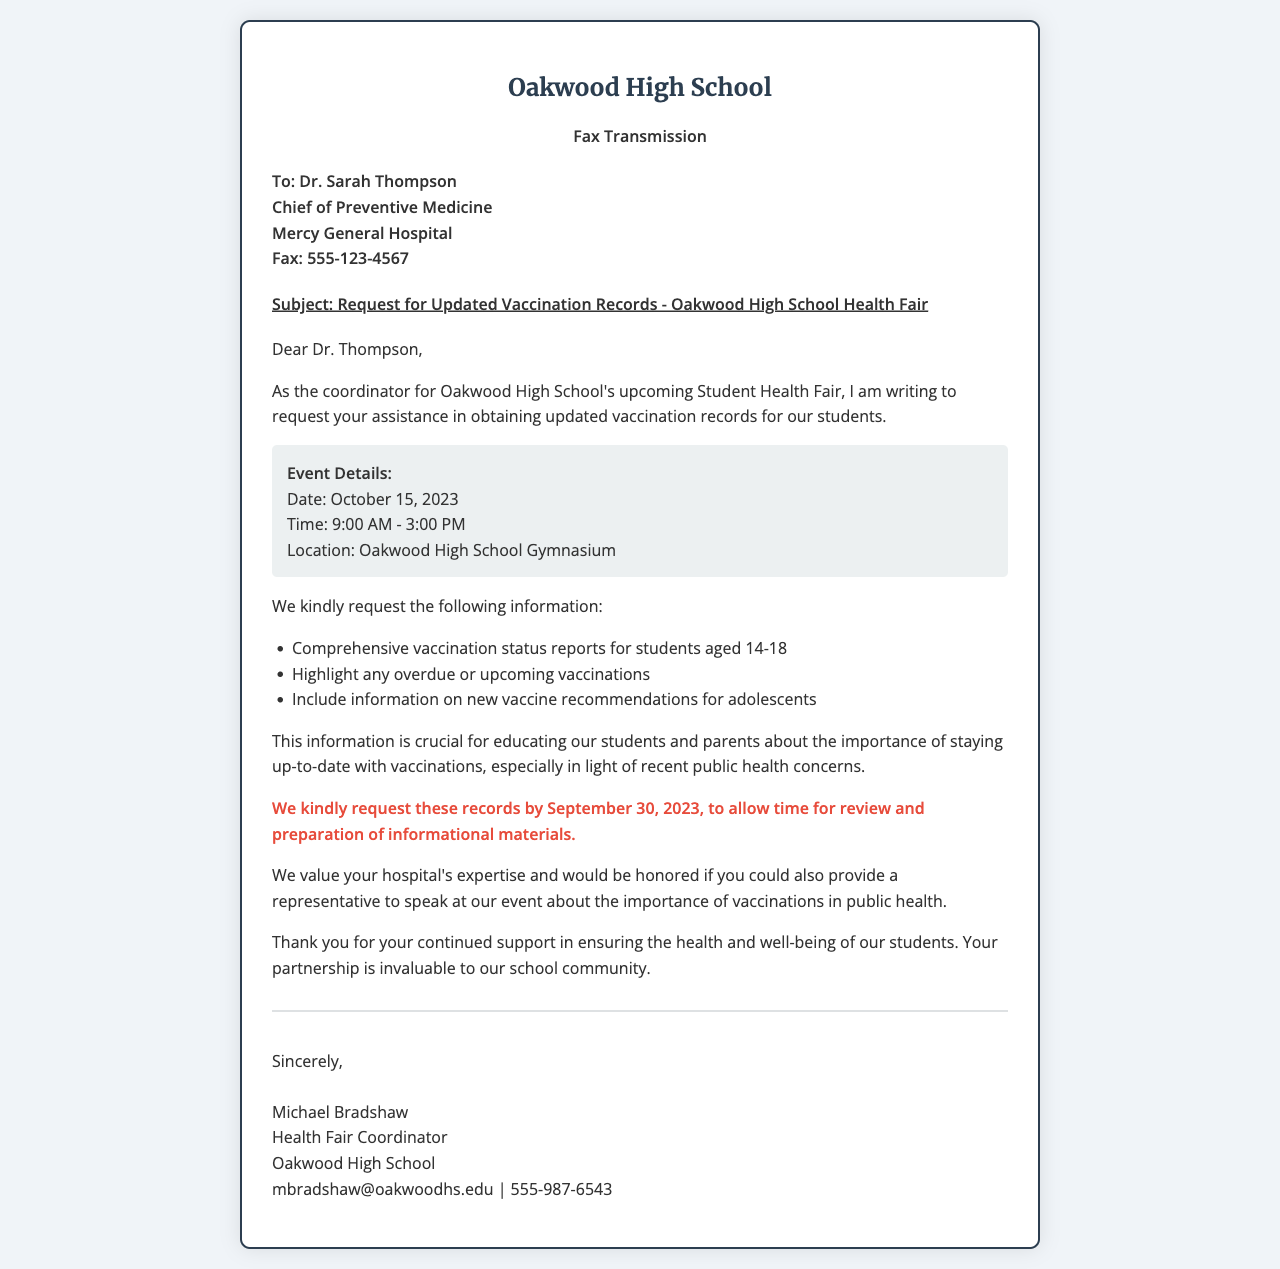What is the date of the health fair? The date of the health fair is stated as October 15, 2023.
Answer: October 15, 2023 Who is the recipient of the fax? The recipient of the fax is Dr. Sarah Thompson, Chief of Preventive Medicine at Mercy General Hospital.
Answer: Dr. Sarah Thompson What specific information is requested regarding vaccinations? The request includes comprehensive vaccination status reports for students aged 14-18, overdue or upcoming vaccinations, and new vaccine recommendations for adolescents.
Answer: Comprehensive vaccination status reports for students aged 14-18 What is the deadline for submitting the vaccination records? The document specifies that the records are requested by September 30, 2023, for review and preparation.
Answer: September 30, 2023 What time does the health fair start? The health fair's start time is recorded as 9:00 AM.
Answer: 9:00 AM Why is the vaccination information considered crucial? The document mentions that this information is important for educating students and parents about vaccinations amidst public health concerns.
Answer: Public health concerns What is the main purpose of this fax? The main purpose of the fax is to request updated vaccination records for students in preparation for an upcoming health fair.
Answer: Request updated vaccination records What role does Michael Bradshaw hold at Oakwood High School? Michael Bradshaw is identified as the Health Fair Coordinator in the document.
Answer: Health Fair Coordinator 